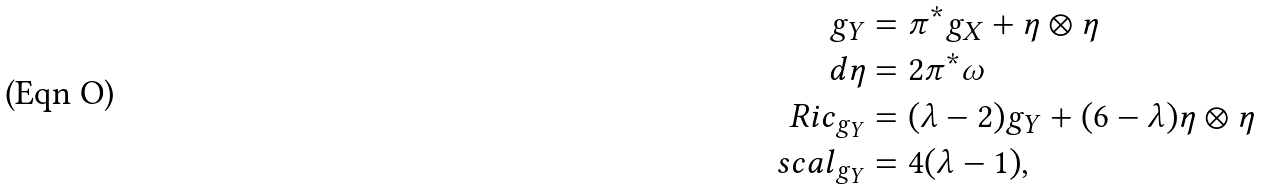Convert formula to latex. <formula><loc_0><loc_0><loc_500><loc_500>g _ { Y } & = \pi ^ { * } g _ { X } + \eta \otimes \eta \\ d \eta & = 2 \pi ^ { * } \omega \\ R i c _ { g _ { Y } } & = ( \lambda - 2 ) g _ { Y } + ( 6 - \lambda ) \eta \otimes \eta \\ s c a l _ { g _ { Y } } & = 4 ( \lambda - 1 ) ,</formula> 